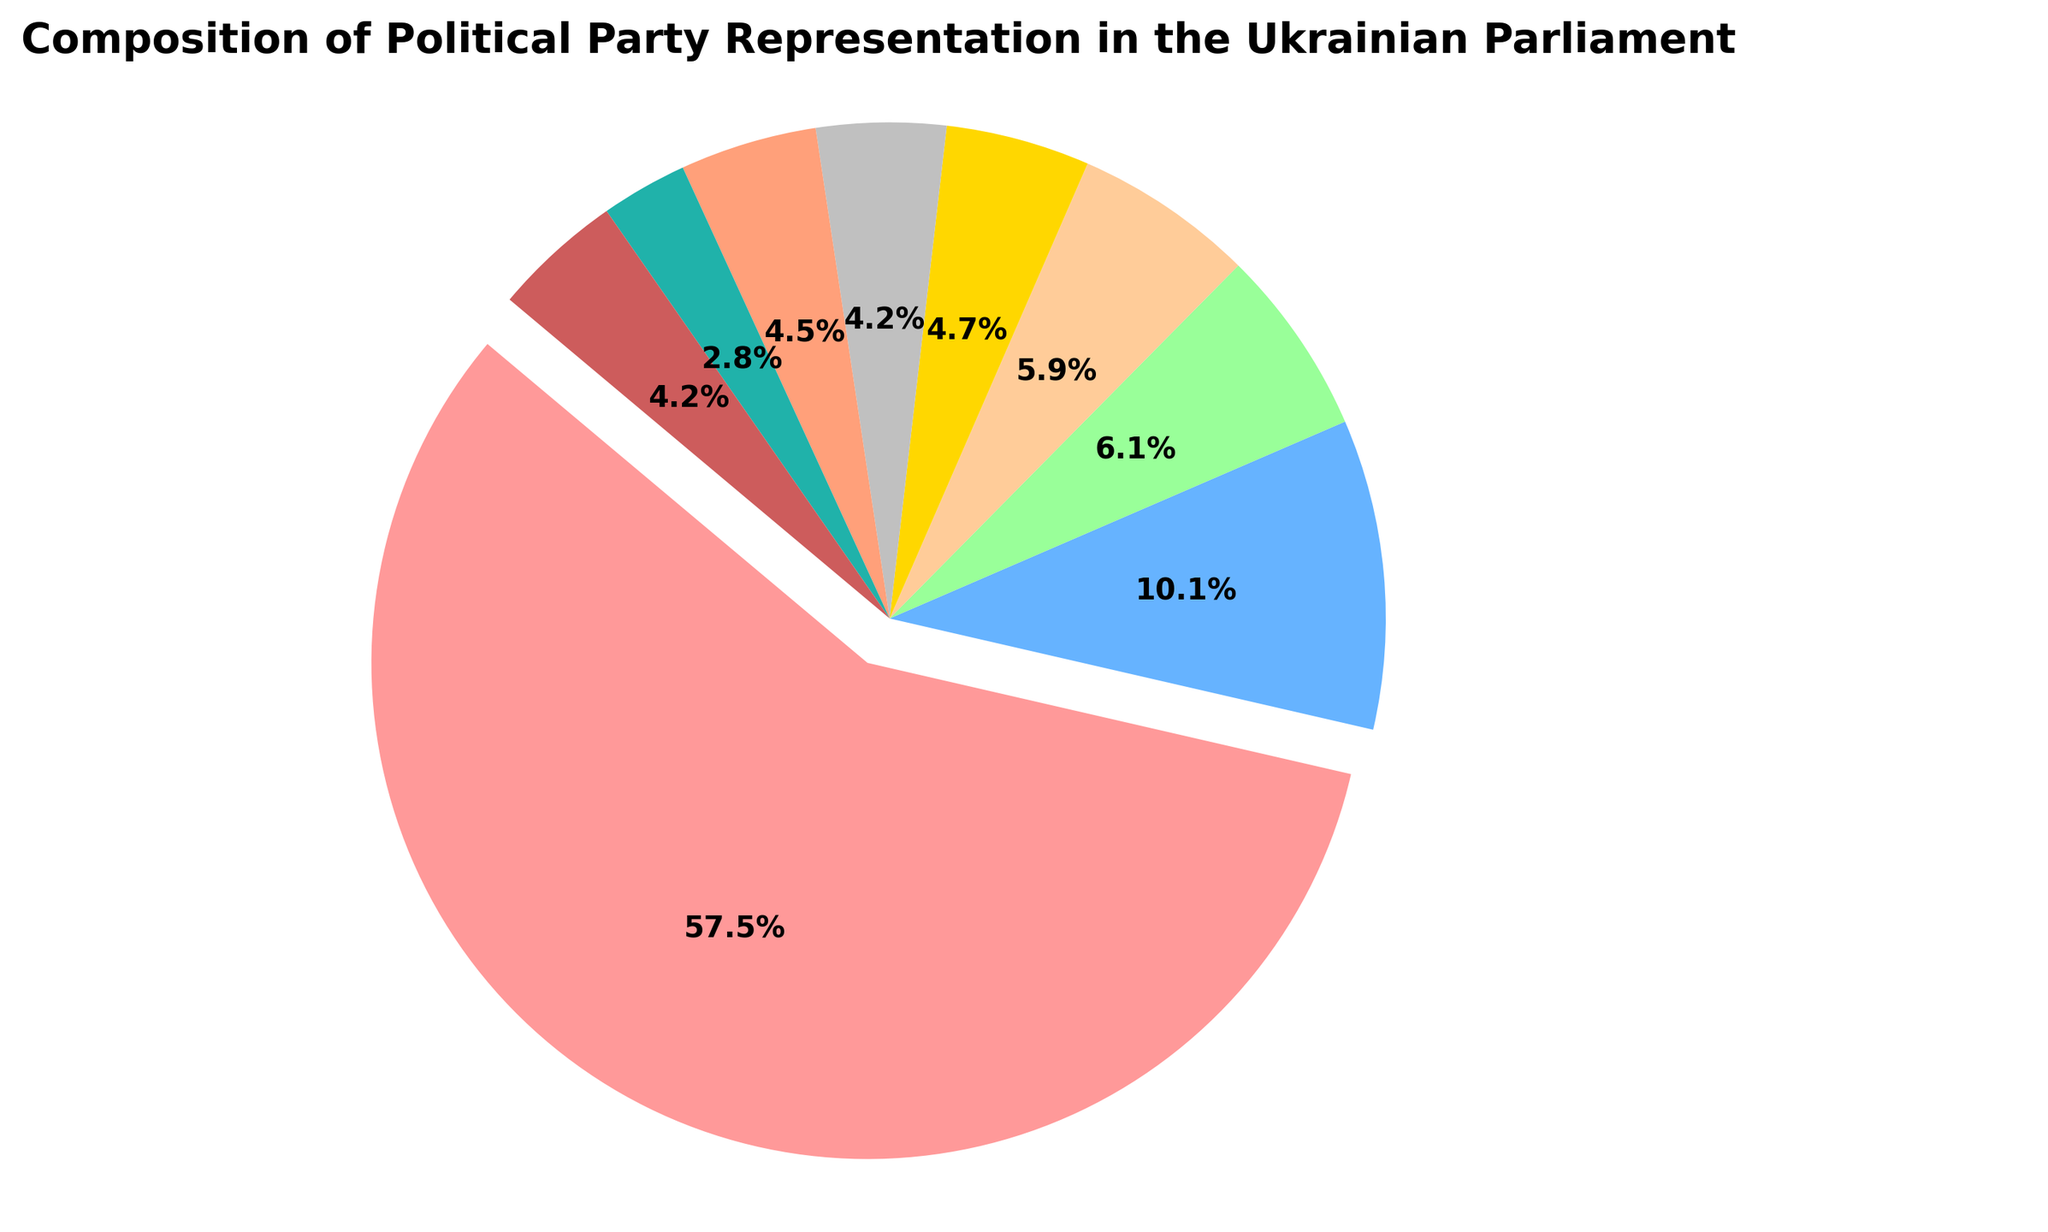What's the largest party in the Ukrainian Parliament in terms of seats? The largest party can be identified by the slice of the pie chart that has the highest percentage. The "Servant of the People" party has a significantly larger slice than the others.
Answer: Servant of the People Which party has slightly fewer seats, "Fatherland" or "European Solidarity"? By comparing the slices, "Fatherland" appears to have a slightly larger slice than "European Solidarity". Thus, "European Solidarity" has slightly fewer seats.
Answer: European Solidarity What is the total number of seats represented by the three smallest parties? The three smallest parties are "Parties of Mayors", "For the Future", and "Other", with the following seats: 12, 18, and 18 respectively. The total is 12 + 18 + 18 = 48 seats.
Answer: 48 Of the "Servant of the People" and "Opposition Platform – For Life", which party has more than double the seats of the other? The "Servant of the People" party has 245 seats, and the "Opposition Platform – For Life" has 43 seats. 245 is more than double of 43 (as 43 * 2 = 86, and 245 > 86).
Answer: Servant of the People What percentage of seats does the "Servant of the People" party hold? The slice of the "Servant of the People" party on the pie chart shows 54.2%. This figure directly tells the percentage of seats they hold.
Answer: 54.2% By how many seats does "Holos" exceed "Parties of Mayors"? "Holos" has 20 seats, while "Parties of Mayors" has 12 seats. The difference in seats is 20 - 12 = 8 seats.
Answer: 8 What is the total number of seats represented by the three parties with the highest representation? The three parties with the highest representation are "Servant of the People" (245), "Opposition Platform – For Life" (43), and "Fatherland" (26). The total is 245 + 43 + 26 = 314 seats.
Answer: 314 If "For the Future" and "Dovira" merged their seats, would they hold more seats than "European Solidarity"? "For the Future" has 18 seats and "Dovira" has 19 seats. Combined, they would have 18 + 19 = 37 seats, which is greater than the 25 seats of "European Solidarity".
Answer: Yes Which parties have less than 20 seats in the Parliament? Observing the slices, "Fatherland" (26), "European Solidarity" (25), "Holos" (20), "For the Future" (18), "Dovira" (19), "Parties of Mayors" (12), and "Other" (18). Parties with fewer than 20 seats are "For the Future", "Dovira", "Parties of Mayors", and "Other".
Answer: For the Future, Dovira, Parties of Mayors, Other 